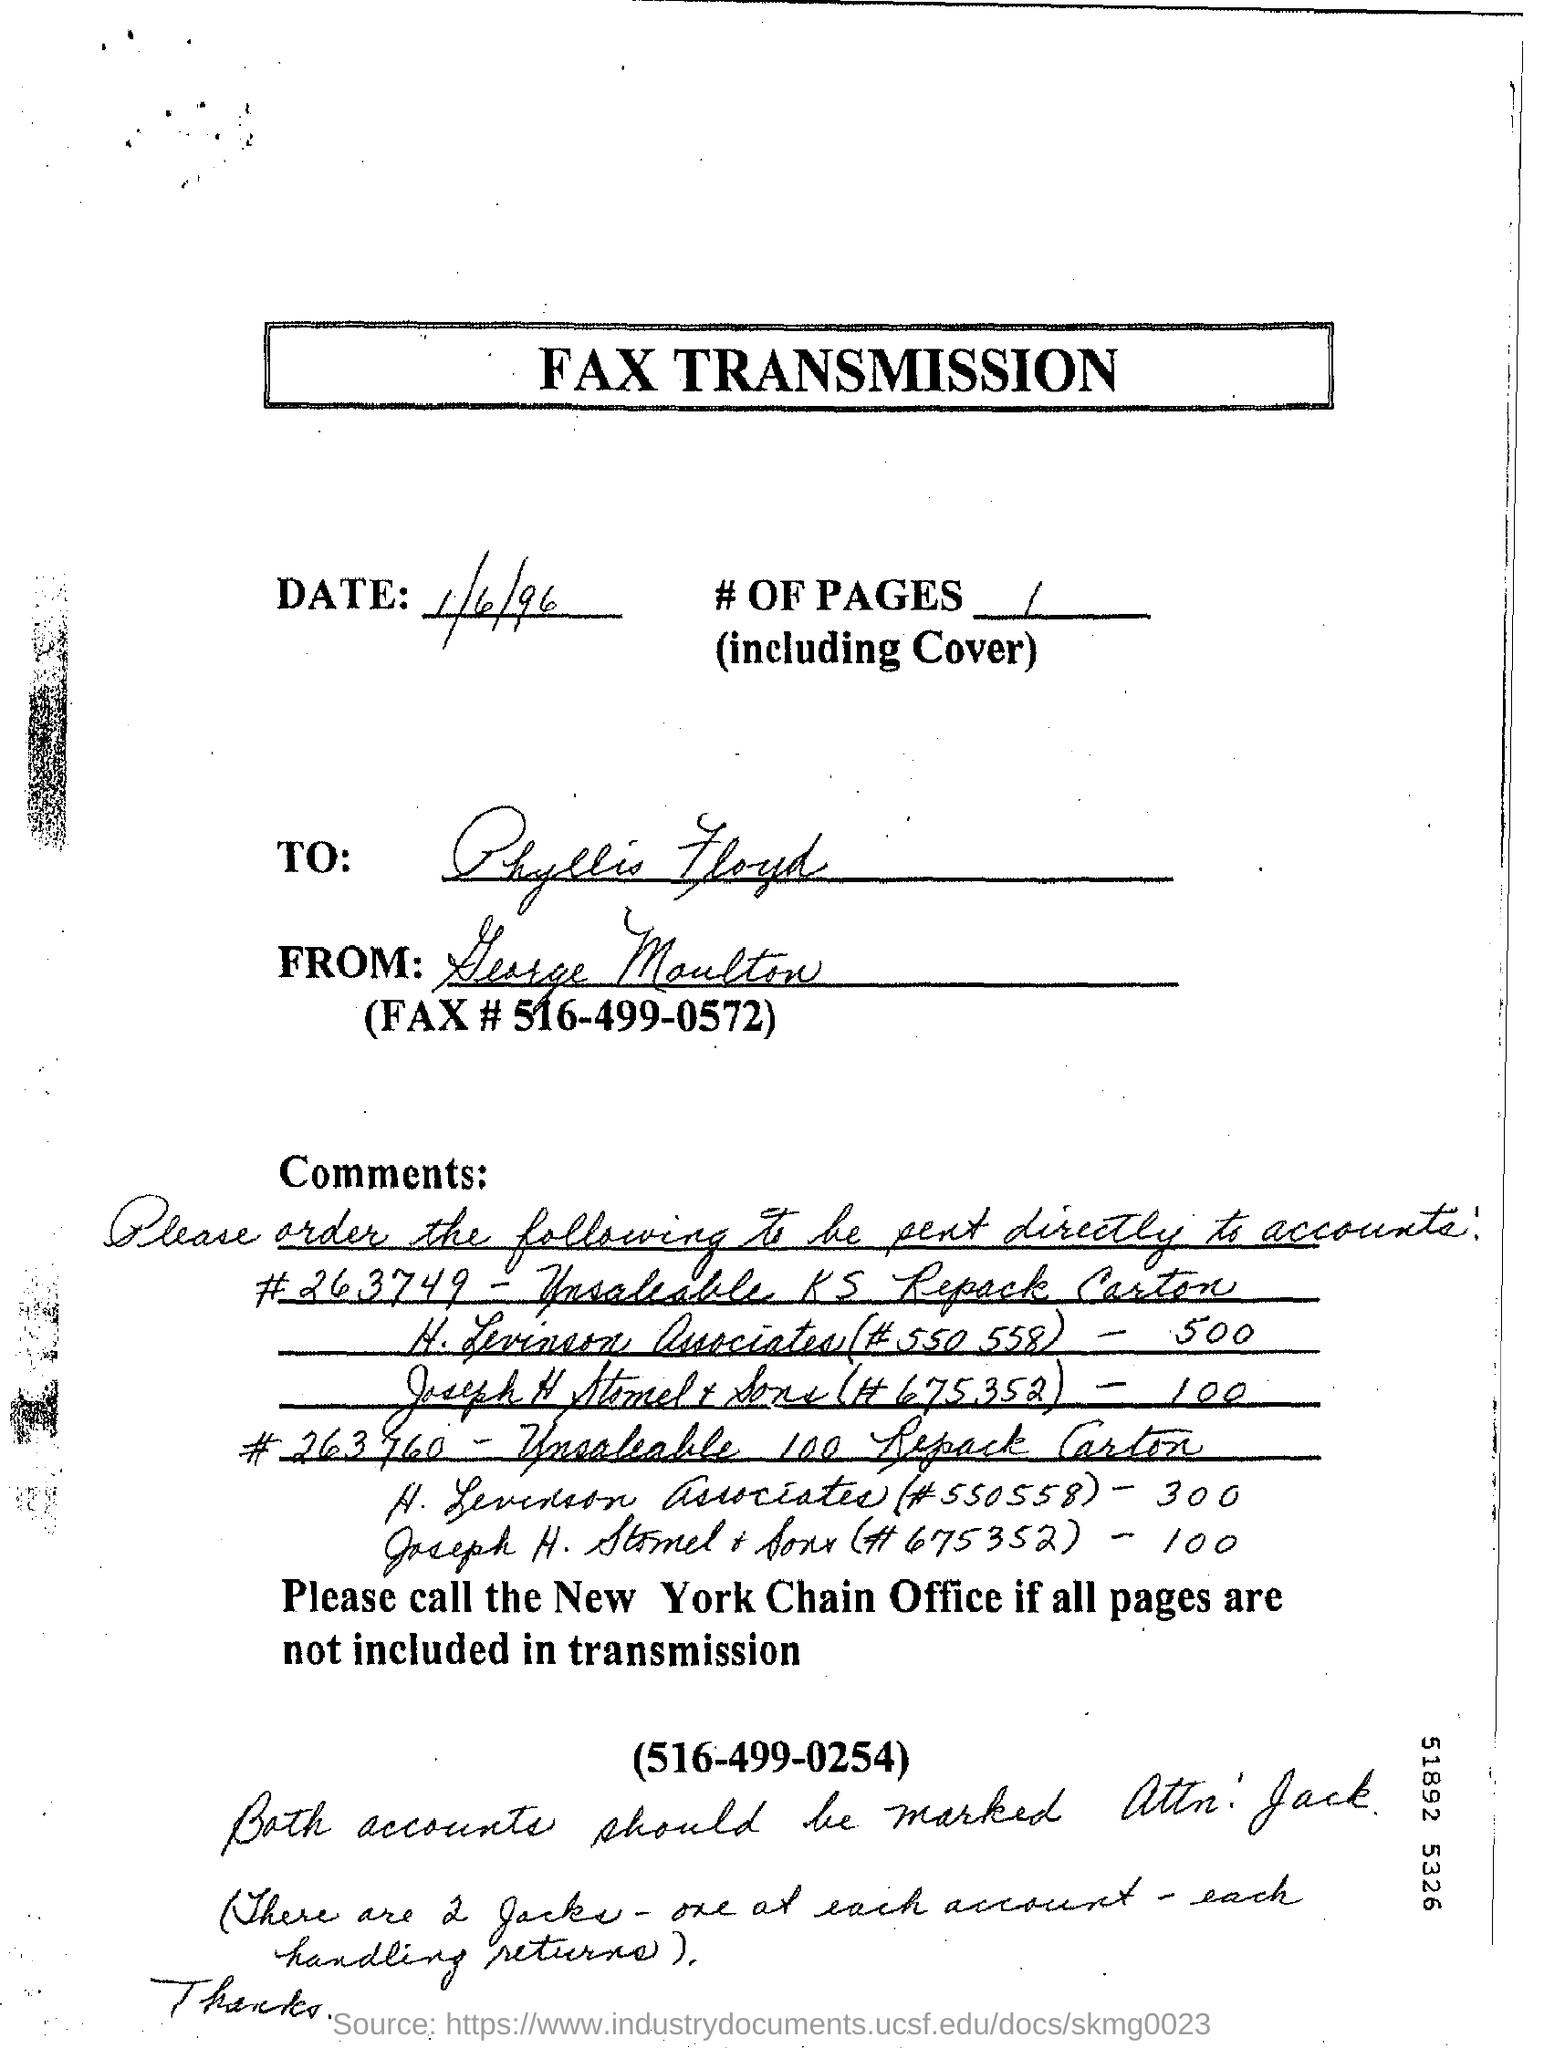Point out several critical features in this image. I am a document entitled 'FAX TRANSMISSION...' 